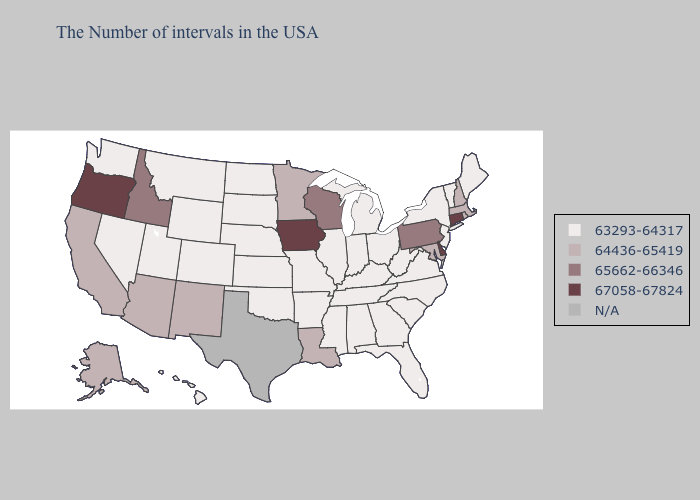Which states have the lowest value in the West?
Short answer required. Wyoming, Colorado, Utah, Montana, Nevada, Washington, Hawaii. Does New Mexico have the lowest value in the West?
Concise answer only. No. Name the states that have a value in the range 67058-67824?
Keep it brief. Connecticut, Delaware, Iowa, Oregon. Among the states that border New Hampshire , which have the lowest value?
Be succinct. Maine, Vermont. Name the states that have a value in the range 63293-64317?
Give a very brief answer. Maine, Vermont, New York, New Jersey, Virginia, North Carolina, South Carolina, West Virginia, Ohio, Florida, Georgia, Michigan, Kentucky, Indiana, Alabama, Tennessee, Illinois, Mississippi, Missouri, Arkansas, Kansas, Nebraska, Oklahoma, South Dakota, North Dakota, Wyoming, Colorado, Utah, Montana, Nevada, Washington, Hawaii. What is the highest value in the South ?
Short answer required. 67058-67824. Which states have the highest value in the USA?
Answer briefly. Connecticut, Delaware, Iowa, Oregon. Which states have the lowest value in the West?
Write a very short answer. Wyoming, Colorado, Utah, Montana, Nevada, Washington, Hawaii. Does the first symbol in the legend represent the smallest category?
Answer briefly. Yes. What is the value of Massachusetts?
Write a very short answer. 64436-65419. What is the highest value in states that border Oklahoma?
Be succinct. 64436-65419. What is the value of Washington?
Keep it brief. 63293-64317. How many symbols are there in the legend?
Be succinct. 5. 